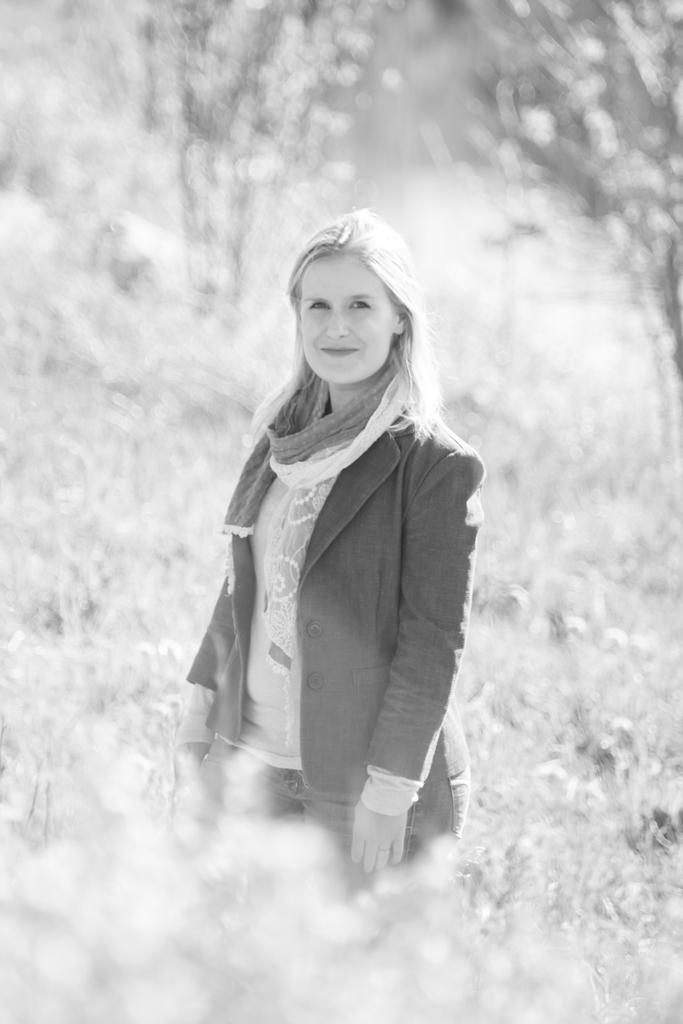What is the color scheme of the image? The image is black and white. Who or what can be seen in the image? There is a woman standing in the image. Where is the woman standing? The woman is standing on the ground. What type of vegetation is present in the image? There are plants and trees in the image. What type of rice is being served at the attraction in the image? There is no attraction or rice present in the image; it features a woman standing on the ground amidst plants and trees. 